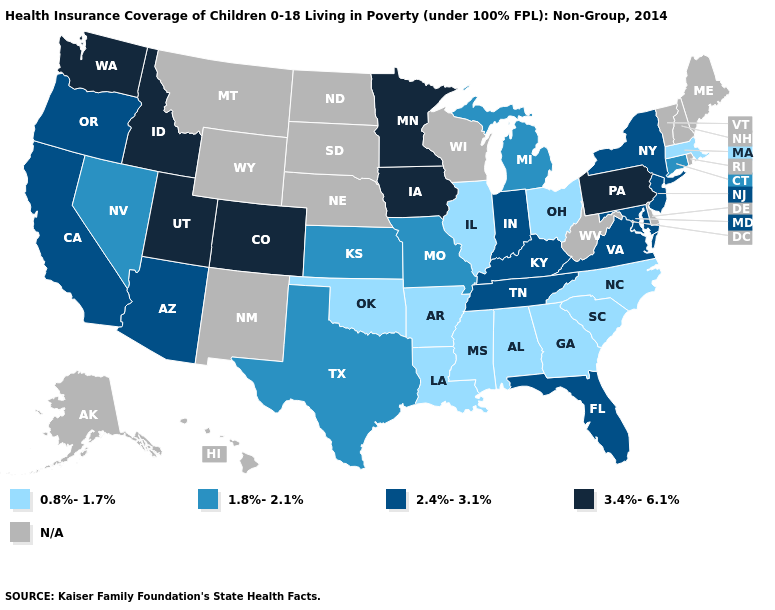What is the value of Idaho?
Short answer required. 3.4%-6.1%. Name the states that have a value in the range 0.8%-1.7%?
Answer briefly. Alabama, Arkansas, Georgia, Illinois, Louisiana, Massachusetts, Mississippi, North Carolina, Ohio, Oklahoma, South Carolina. Which states hav the highest value in the MidWest?
Concise answer only. Iowa, Minnesota. Does the first symbol in the legend represent the smallest category?
Write a very short answer. Yes. Name the states that have a value in the range N/A?
Answer briefly. Alaska, Delaware, Hawaii, Maine, Montana, Nebraska, New Hampshire, New Mexico, North Dakota, Rhode Island, South Dakota, Vermont, West Virginia, Wisconsin, Wyoming. Does Nevada have the lowest value in the West?
Keep it brief. Yes. Name the states that have a value in the range 0.8%-1.7%?
Concise answer only. Alabama, Arkansas, Georgia, Illinois, Louisiana, Massachusetts, Mississippi, North Carolina, Ohio, Oklahoma, South Carolina. Name the states that have a value in the range 0.8%-1.7%?
Concise answer only. Alabama, Arkansas, Georgia, Illinois, Louisiana, Massachusetts, Mississippi, North Carolina, Ohio, Oklahoma, South Carolina. Which states have the highest value in the USA?
Write a very short answer. Colorado, Idaho, Iowa, Minnesota, Pennsylvania, Utah, Washington. Name the states that have a value in the range 2.4%-3.1%?
Be succinct. Arizona, California, Florida, Indiana, Kentucky, Maryland, New Jersey, New York, Oregon, Tennessee, Virginia. Among the states that border New York , which have the highest value?
Give a very brief answer. Pennsylvania. Among the states that border North Dakota , which have the lowest value?
Concise answer only. Minnesota. What is the highest value in the MidWest ?
Be succinct. 3.4%-6.1%. Does Missouri have the lowest value in the MidWest?
Be succinct. No. What is the lowest value in the USA?
Be succinct. 0.8%-1.7%. 